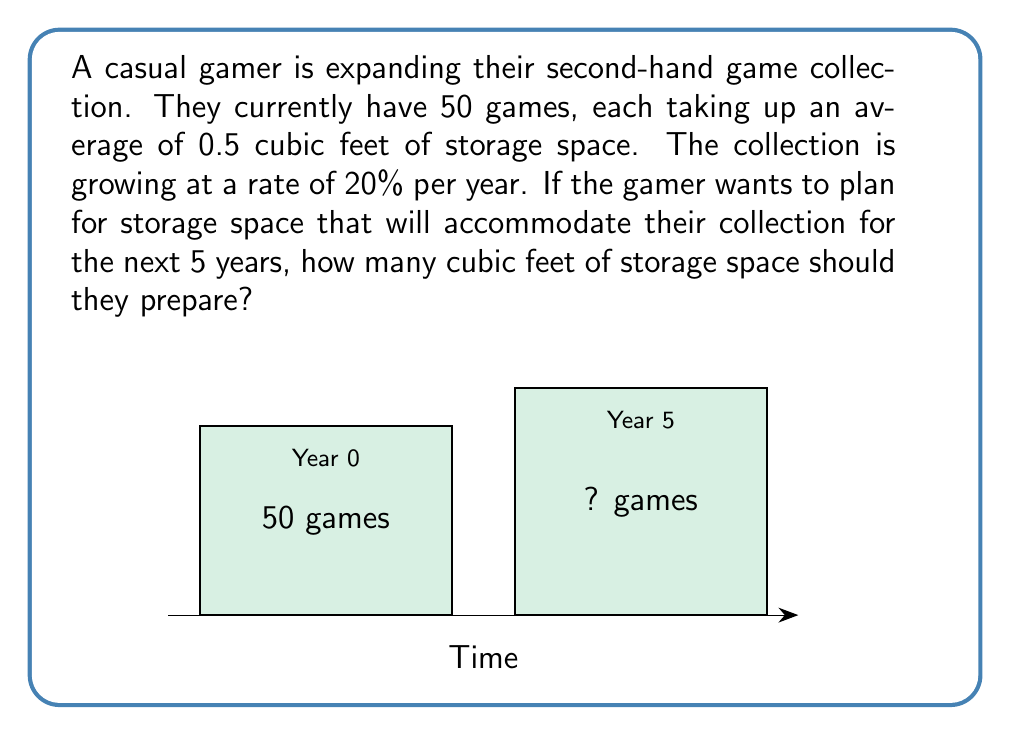Help me with this question. Let's approach this step-by-step:

1) First, we need to calculate how many games the collection will grow to in 5 years.
   - Initial number of games: 50
   - Growth rate: 20% = 0.2 per year
   - Time: 5 years

   We can use the compound growth formula:
   $$ \text{Final Amount} = \text{Initial Amount} \times (1 + \text{Growth Rate})^{\text{Time}} $$
   $$ \text{Final Number of Games} = 50 \times (1 + 0.2)^5 $$

2) Let's calculate this:
   $$ 50 \times (1.2)^5 = 50 \times 2.4883 = 124.415 $$

3) Rounding up to the nearest whole number, we get 125 games.

4) Now, we need to calculate the storage space needed for 125 games.
   - Each game takes up 0.5 cubic feet
   $$ \text{Total Space} = \text{Number of Games} \times \text{Space per Game} $$
   $$ \text{Total Space} = 125 \times 0.5 = 62.5 \text{ cubic feet} $$

5) To ensure we have enough space, we should round up to the nearest whole number.

Therefore, the gamer should prepare 63 cubic feet of storage space.
Answer: 63 cubic feet 